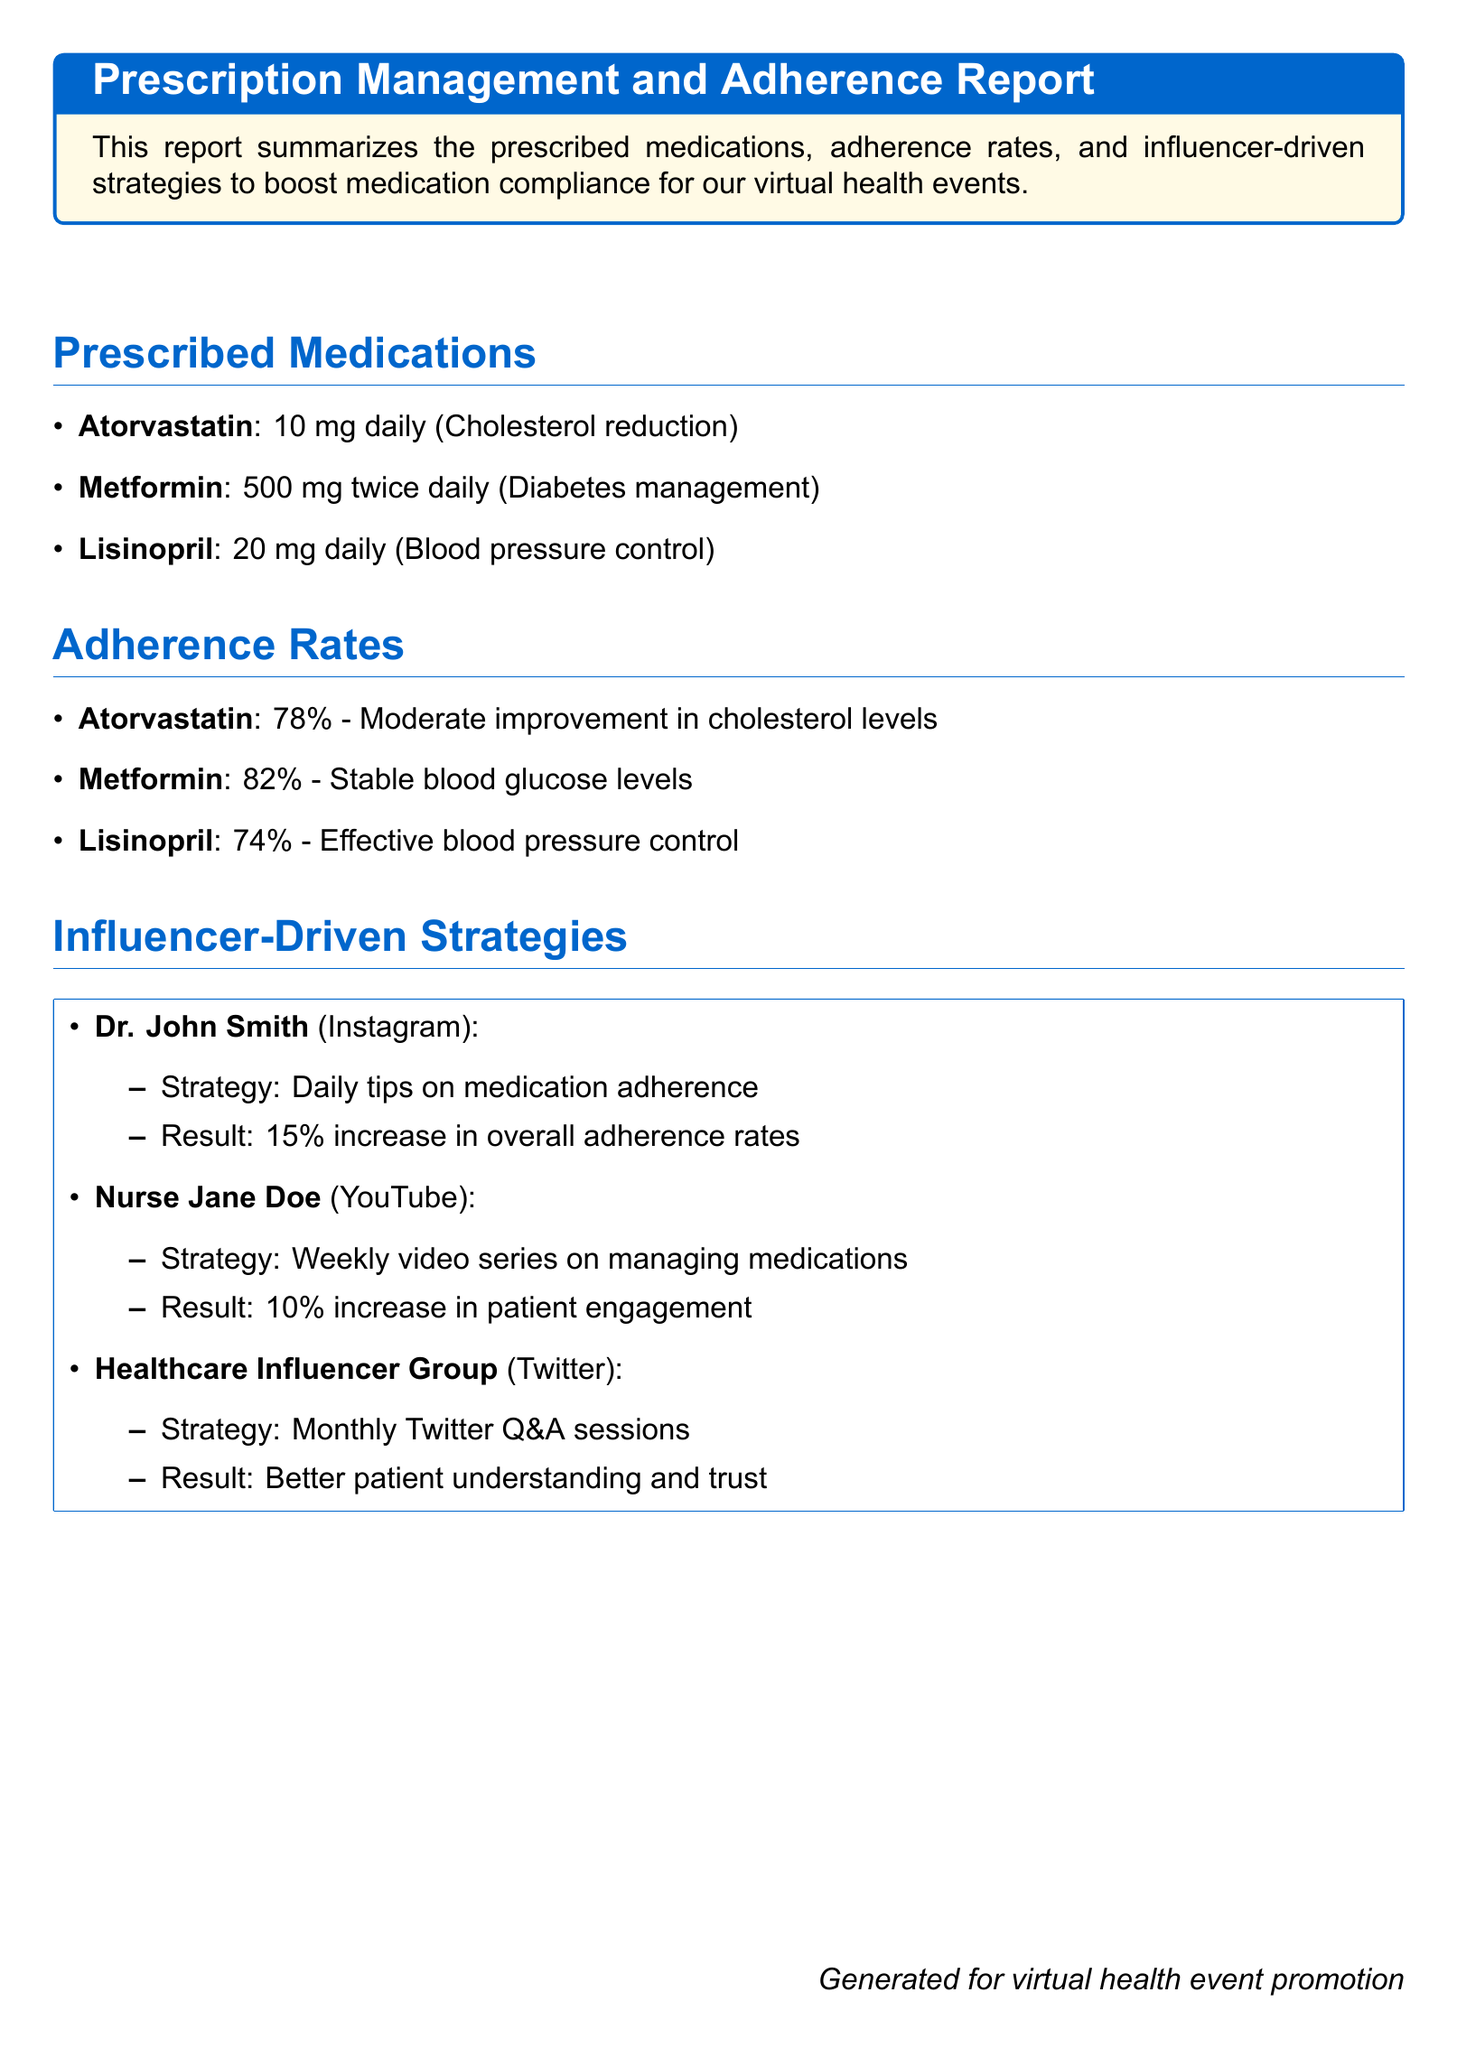What medications are prescribed? The prescribed medications are listed under the section "Prescribed Medications," which includes Atorvastatin, Metformin, and Lisinopril.
Answer: Atorvastatin, Metformin, Lisinopril What is the adherence rate for Metformin? The adherence rate for Metformin is mentioned in the "Adherence Rates" section of the document.
Answer: 82% What increase in adherence rates resulted from Dr. John Smith's strategy? The strategy's effectiveness is summarized under "Influencer-Driven Strategies", where Dr. John Smith's results show a specific percentage increase.
Answer: 15% What medication is associated with cholesterol reduction? The medication intended for cholesterol reduction is identified in the "Prescribed Medications" section.
Answer: Atorvastatin Which influencer provided weekly video series on managing medications? The document specifies which influencer provided this service in the "Influencer-Driven Strategies".
Answer: Nurse Jane Doe What is the adherence rate for Lisinopril? The adherence rate for Lisinopril is detailed in the "Adherence Rates" section.
Answer: 74% What was the result of the monthly Twitter Q&A sessions? The outcome of the strategy is described in the "Influencer-Driven Strategies" section, focusing on patient understanding and trust.
Answer: Better patient understanding and trust How many mg of Metformin is prescribed daily? The daily dosage of Metformin can be found in the "Prescribed Medications" section of the document.
Answer: 1000 mg What color is used for the title of the report? The document specifies the color used for the report title in the formatting section.
Answer: Main color 